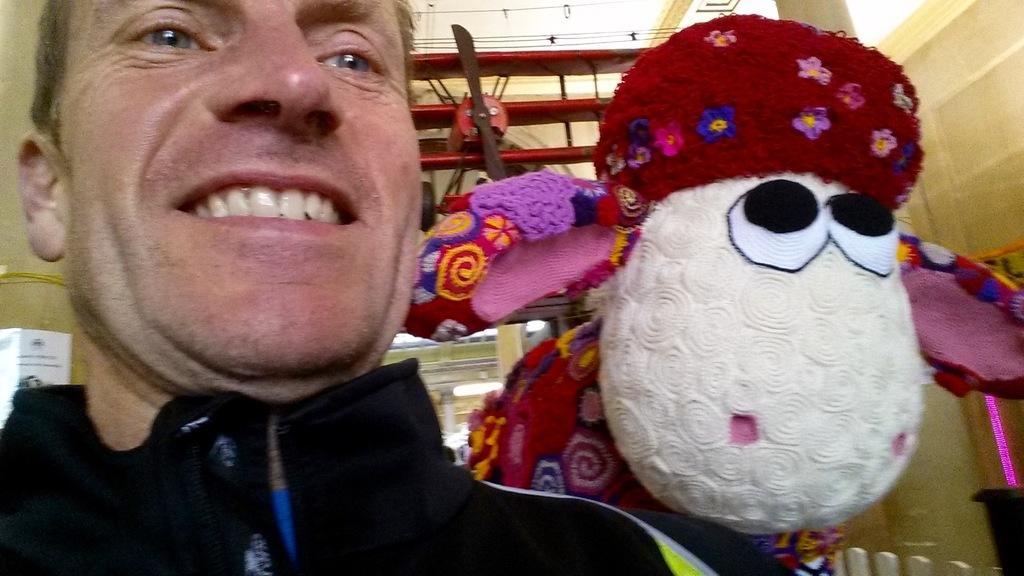Describe this image in one or two sentences. In this image we can see a person wearing black dress. In the background, we can see a doll and an airplane and a light. 